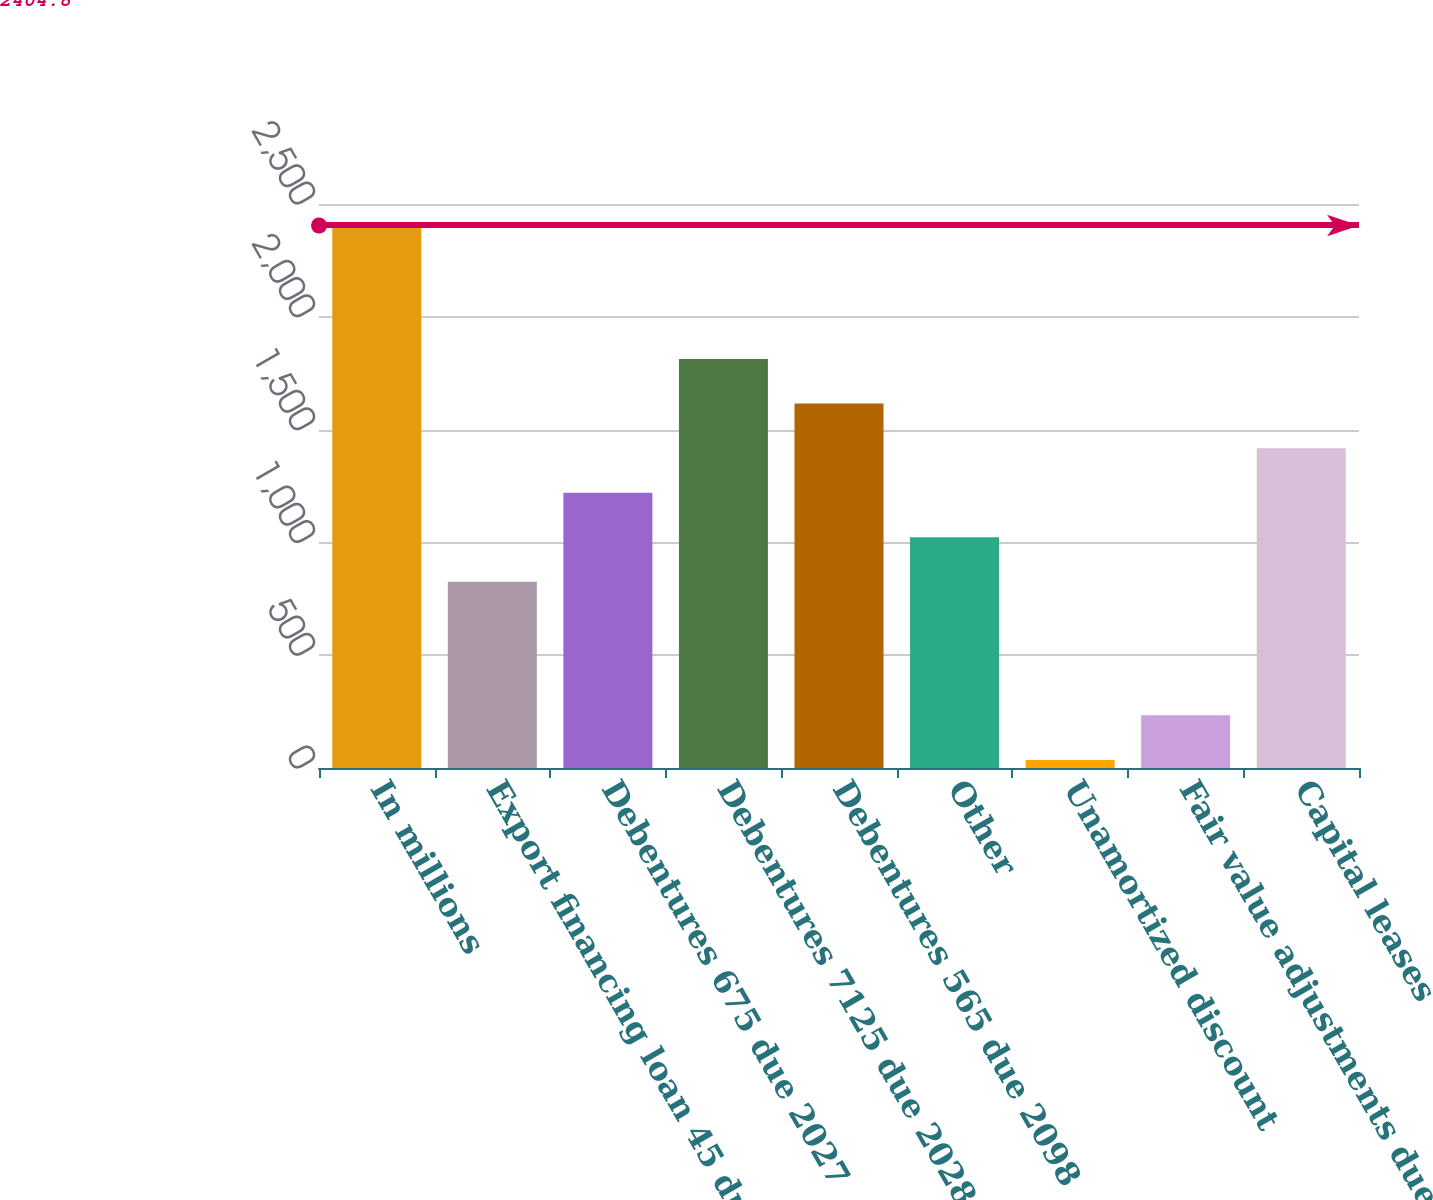Convert chart. <chart><loc_0><loc_0><loc_500><loc_500><bar_chart><fcel>In millions<fcel>Export financing loan 45 due<fcel>Debentures 675 due 2027<fcel>Debentures 7125 due 2028<fcel>Debentures 565 due 2098<fcel>Other<fcel>Unamortized discount<fcel>Fair value adjustments due to<fcel>Capital leases<nl><fcel>2404.8<fcel>825.6<fcel>1220.4<fcel>1812.6<fcel>1615.2<fcel>1023<fcel>36<fcel>233.4<fcel>1417.8<nl></chart> 